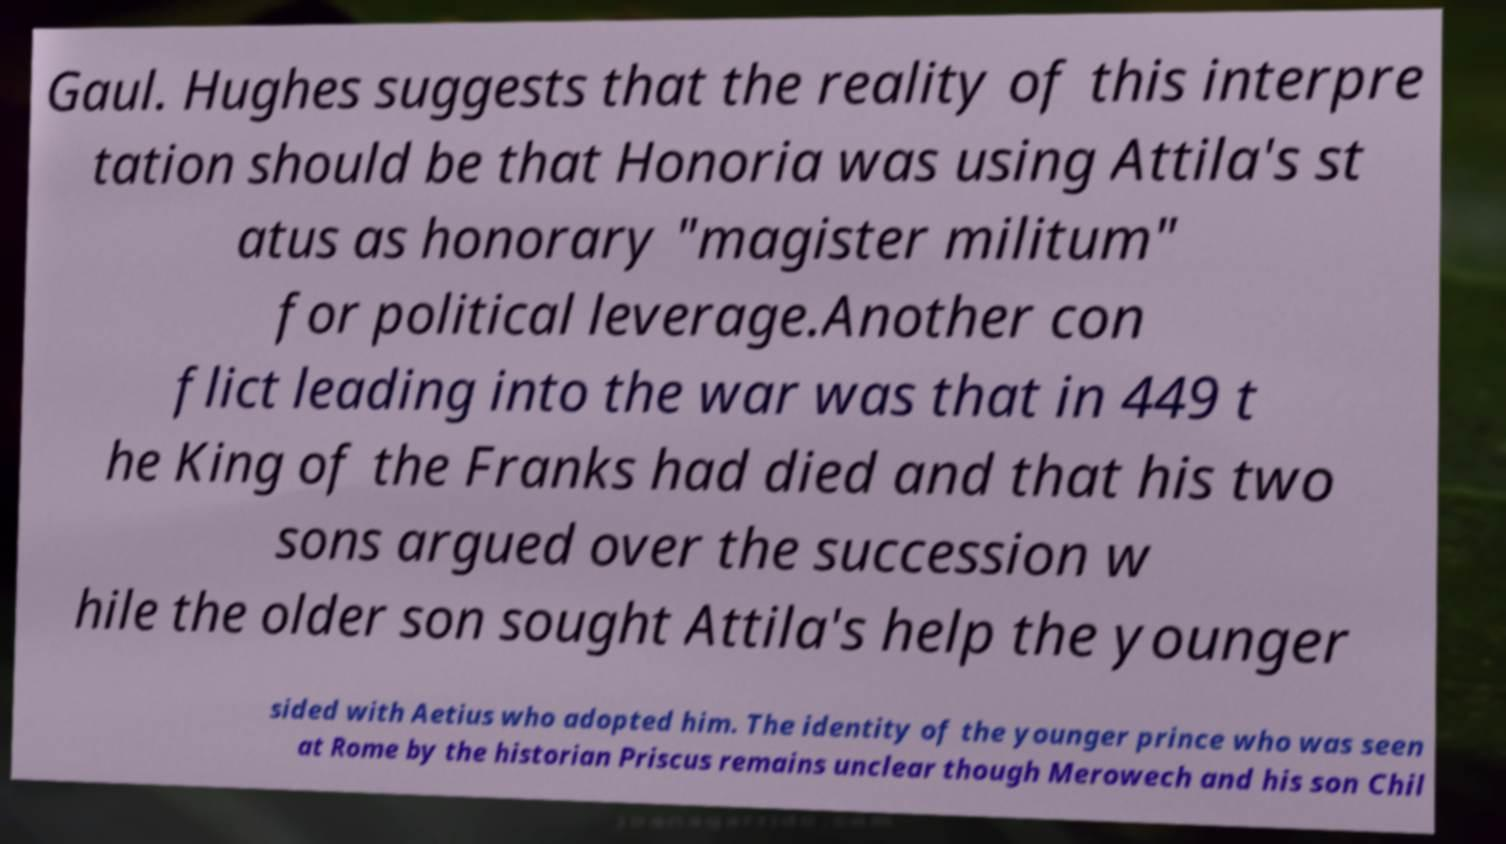Please read and relay the text visible in this image. What does it say? Gaul. Hughes suggests that the reality of this interpre tation should be that Honoria was using Attila's st atus as honorary "magister militum" for political leverage.Another con flict leading into the war was that in 449 t he King of the Franks had died and that his two sons argued over the succession w hile the older son sought Attila's help the younger sided with Aetius who adopted him. The identity of the younger prince who was seen at Rome by the historian Priscus remains unclear though Merowech and his son Chil 